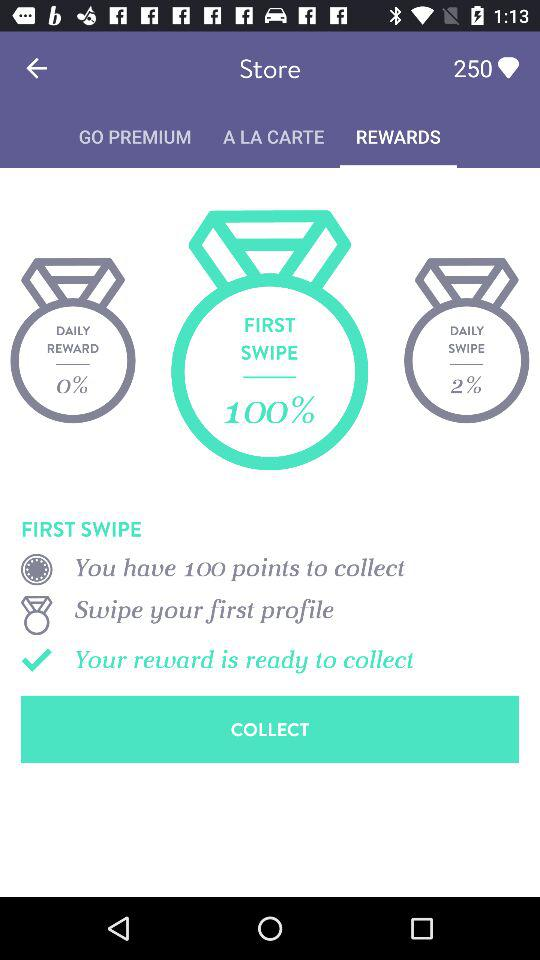What application can the user log in with? The user can log in with "FACEBOOK". 